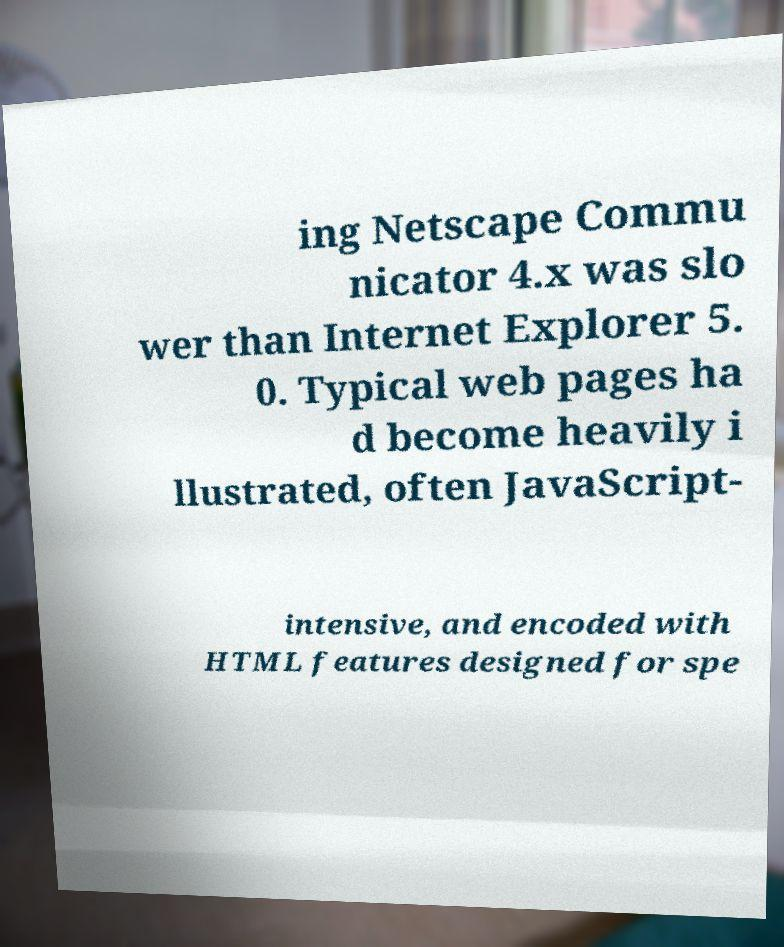I need the written content from this picture converted into text. Can you do that? ing Netscape Commu nicator 4.x was slo wer than Internet Explorer 5. 0. Typical web pages ha d become heavily i llustrated, often JavaScript- intensive, and encoded with HTML features designed for spe 